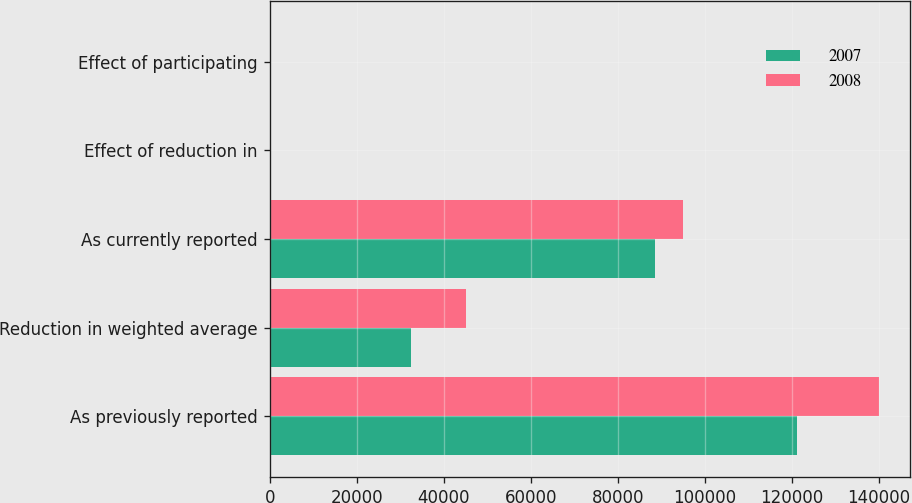<chart> <loc_0><loc_0><loc_500><loc_500><stacked_bar_chart><ecel><fcel>As previously reported<fcel>Reduction in weighted average<fcel>As currently reported<fcel>Effect of reduction in<fcel>Effect of participating<nl><fcel>2007<fcel>121213<fcel>32523<fcel>88690<fcel>1.06<fcel>0.08<nl><fcel>2008<fcel>140137<fcel>45030<fcel>95107<fcel>0.12<fcel>0.05<nl></chart> 